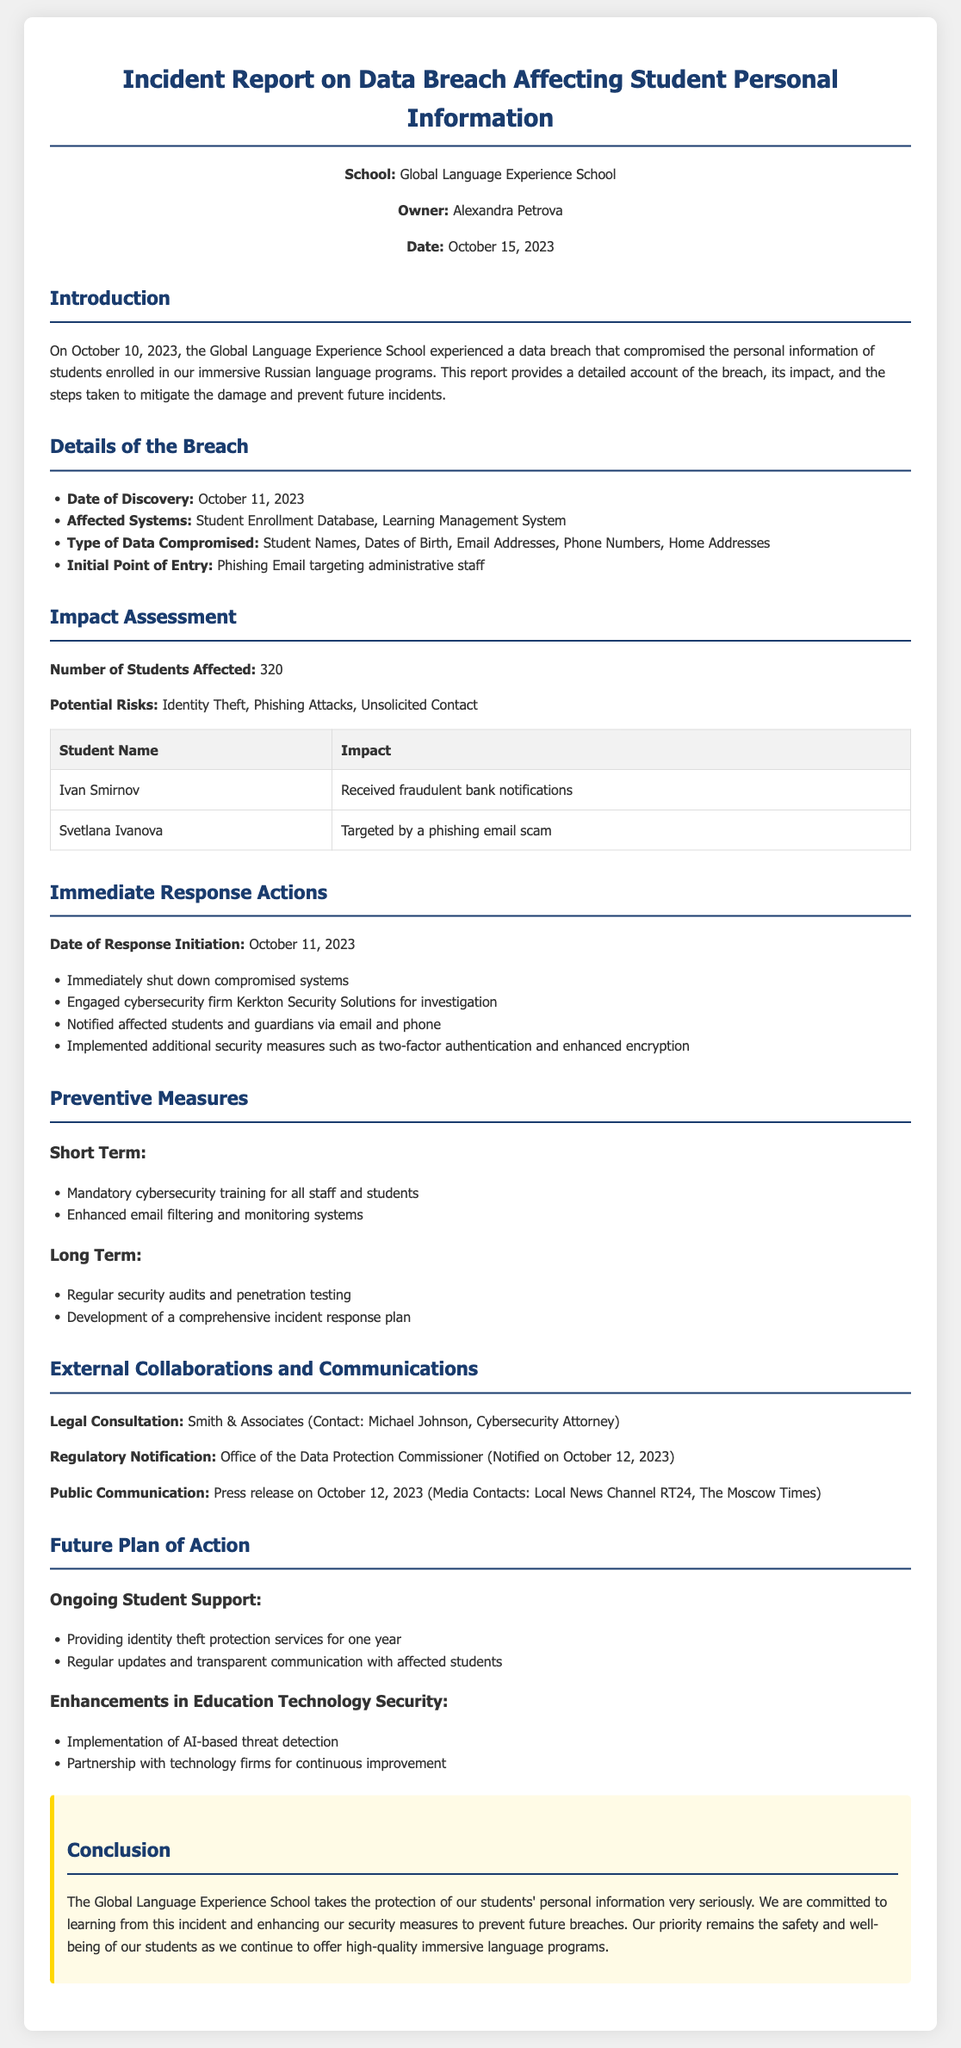What is the date of the incident report? The date of the report is mentioned in the header information, specifically stating "October 15, 2023."
Answer: October 15, 2023 How many students were affected by the breach? The document states that "320" students were affected, which is listed in the impact assessment section.
Answer: 320 What was the initial point of entry for the breach? The document describes "Phishing Email targeting administrative staff" as the initial point of entry in the details of the breach section.
Answer: Phishing Email targeting administrative staff Which cybersecurity firm was engaged for investigation? The report mentions "Kerkton Security Solutions" as the cybersecurity firm engaged for the investigation in the immediate response actions section.
Answer: Kerkton Security Solutions What type of data was compromised? The compromised data types listed include "Student Names, Dates of Birth, Email Addresses, Phone Numbers, Home Addresses."
Answer: Student Names, Dates of Birth, Email Addresses, Phone Numbers, Home Addresses Name one potential risk related to the breach. The document outlines risks such as "Identity Theft, Phishing Attacks, Unsolicited Contact," which are potential risks mentioned in the impact assessment.
Answer: Identity Theft What is one short-term preventive measure mentioned? The section on preventive measures lists "Mandatory cybersecurity training for all staff and students" as a short-term action.
Answer: Mandatory cybersecurity training for all staff and students When was the breach discovered? The breach discovery date is noted as "October 11, 2023" in the details of the breach section.
Answer: October 11, 2023 Who provided legal consultation for the incident? The document states that legal consultation was provided by "Smith & Associates" with a contact named "Michael Johnson."
Answer: Smith & Associates (Michael Johnson) 